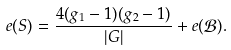Convert formula to latex. <formula><loc_0><loc_0><loc_500><loc_500>e ( S ) = \frac { 4 ( g _ { 1 } - 1 ) ( g _ { 2 } - 1 ) } { | G | } + e ( { \mathcal { B } } ) .</formula> 